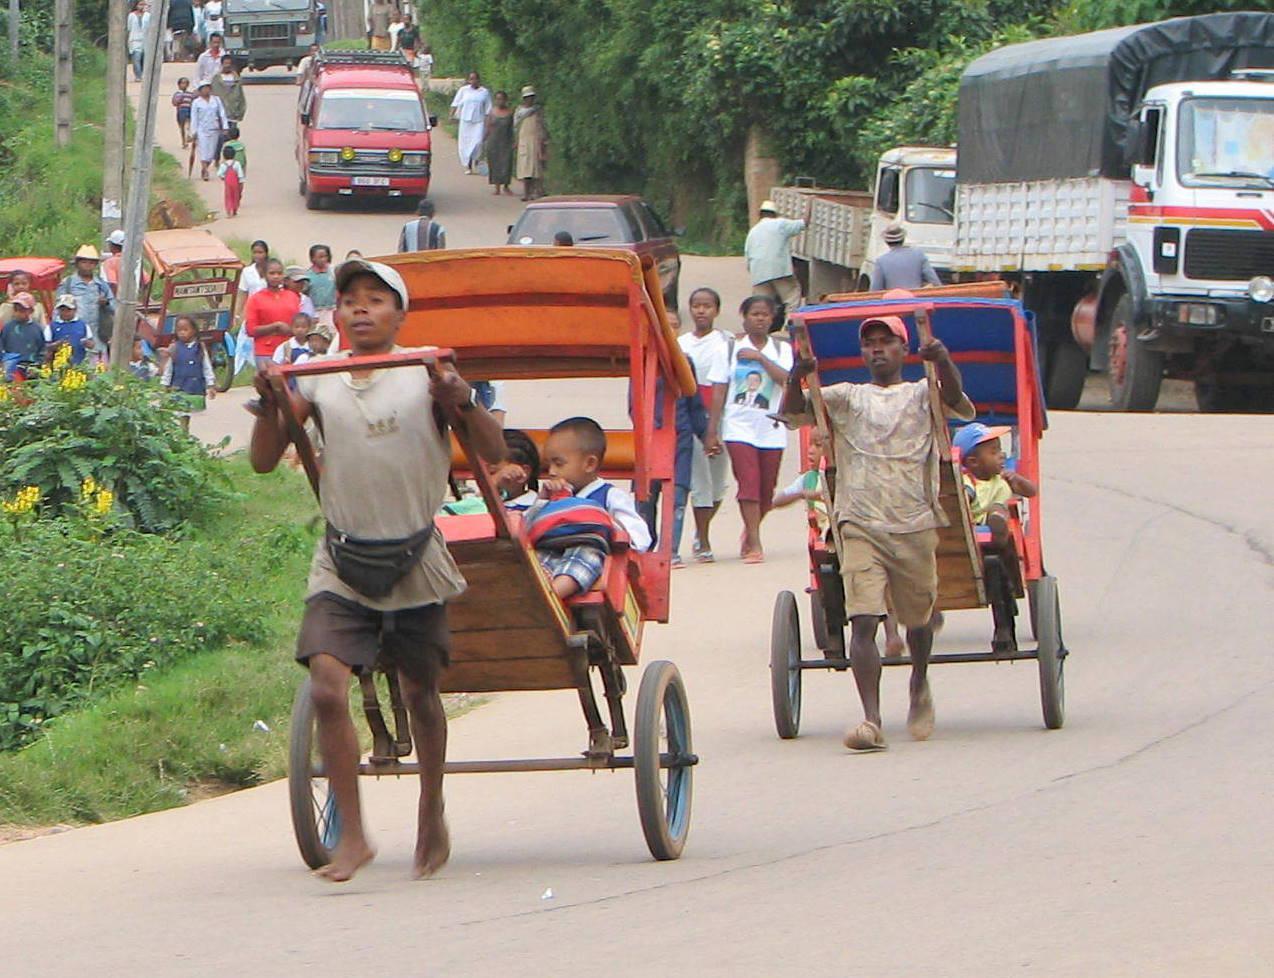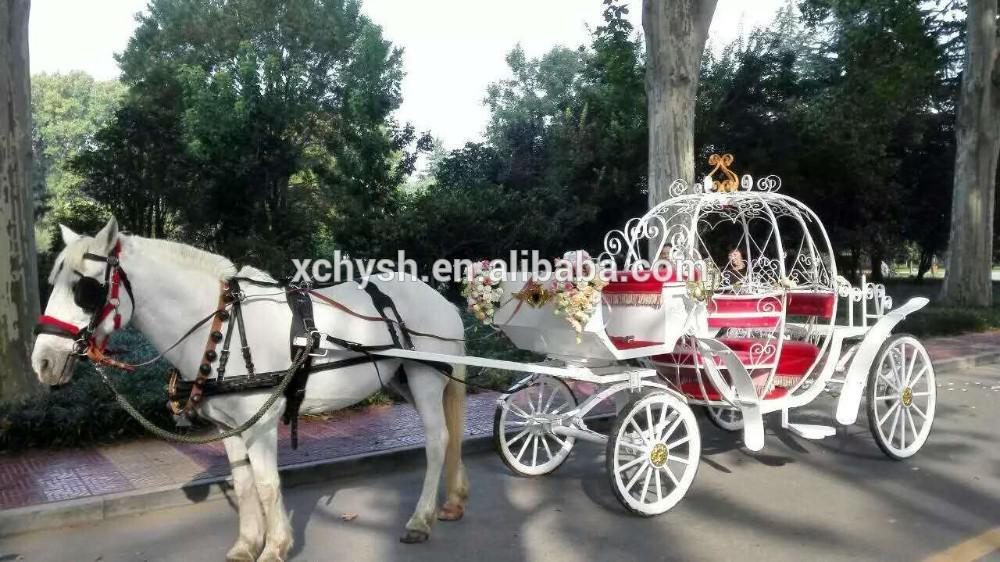The first image is the image on the left, the second image is the image on the right. For the images shown, is this caption "The right image shows a four-wheeled white carriage with some type of top, pulled by one horse facing leftward." true? Answer yes or no. Yes. The first image is the image on the left, the second image is the image on the right. For the images shown, is this caption "The left and right image contains a total of two horses." true? Answer yes or no. No. 